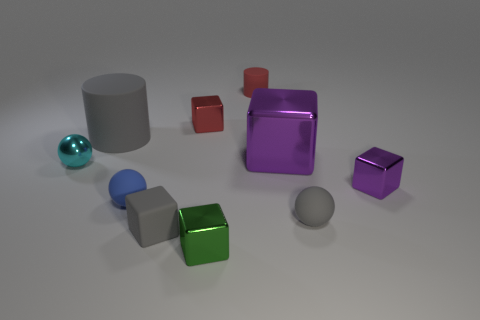Is there anything else that has the same color as the tiny metallic ball?
Your answer should be very brief. No. There is a big object that is made of the same material as the tiny blue object; what is its shape?
Keep it short and to the point. Cylinder. Do the large purple thing and the gray object that is behind the tiny gray rubber ball have the same shape?
Offer a terse response. No. The gray cylinder that is behind the tiny gray matte thing that is behind the gray cube is made of what material?
Your answer should be compact. Rubber. Are there an equal number of small balls that are behind the large metal cube and large blue cubes?
Provide a short and direct response. Yes. There is a metallic object that is to the right of the big purple metal block; is it the same color as the big thing on the right side of the tiny red matte object?
Ensure brevity in your answer.  Yes. What number of tiny objects are on the left side of the green object and on the right side of the tiny red rubber thing?
Give a very brief answer. 0. How many other things are the same shape as the big matte object?
Your answer should be compact. 1. Are there more small cubes in front of the tiny blue object than blue objects?
Make the answer very short. Yes. There is a big object right of the green object; what color is it?
Provide a short and direct response. Purple. 